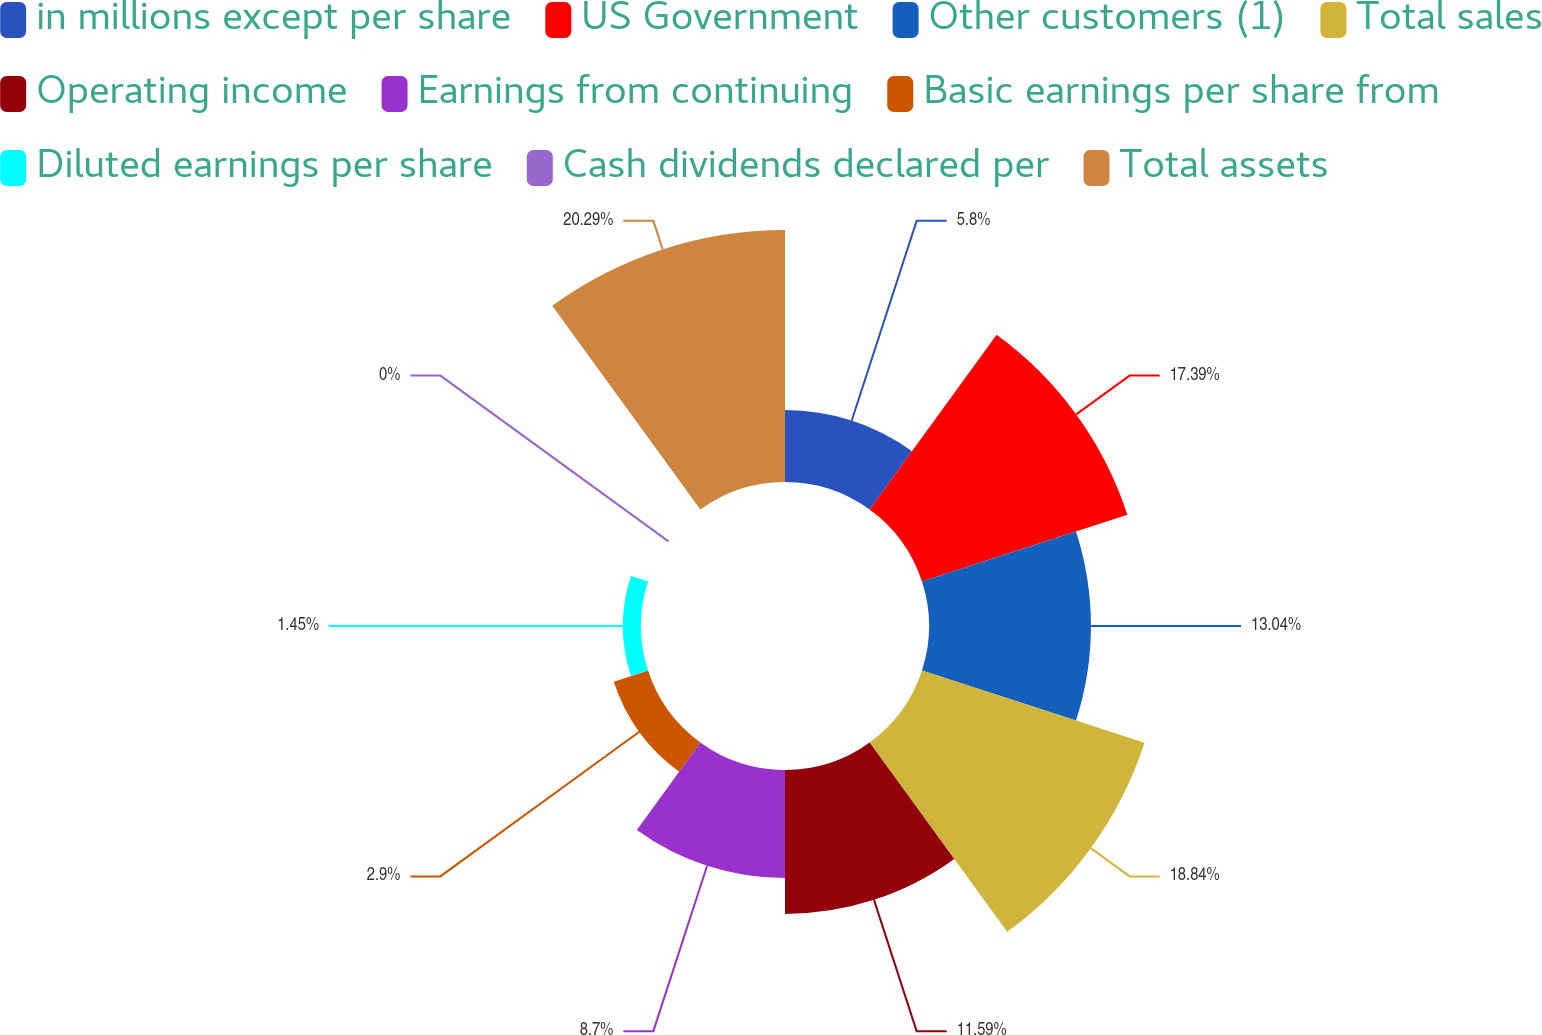<chart> <loc_0><loc_0><loc_500><loc_500><pie_chart><fcel>in millions except per share<fcel>US Government<fcel>Other customers (1)<fcel>Total sales<fcel>Operating income<fcel>Earnings from continuing<fcel>Basic earnings per share from<fcel>Diluted earnings per share<fcel>Cash dividends declared per<fcel>Total assets<nl><fcel>5.8%<fcel>17.39%<fcel>13.04%<fcel>18.84%<fcel>11.59%<fcel>8.7%<fcel>2.9%<fcel>1.45%<fcel>0.0%<fcel>20.29%<nl></chart> 